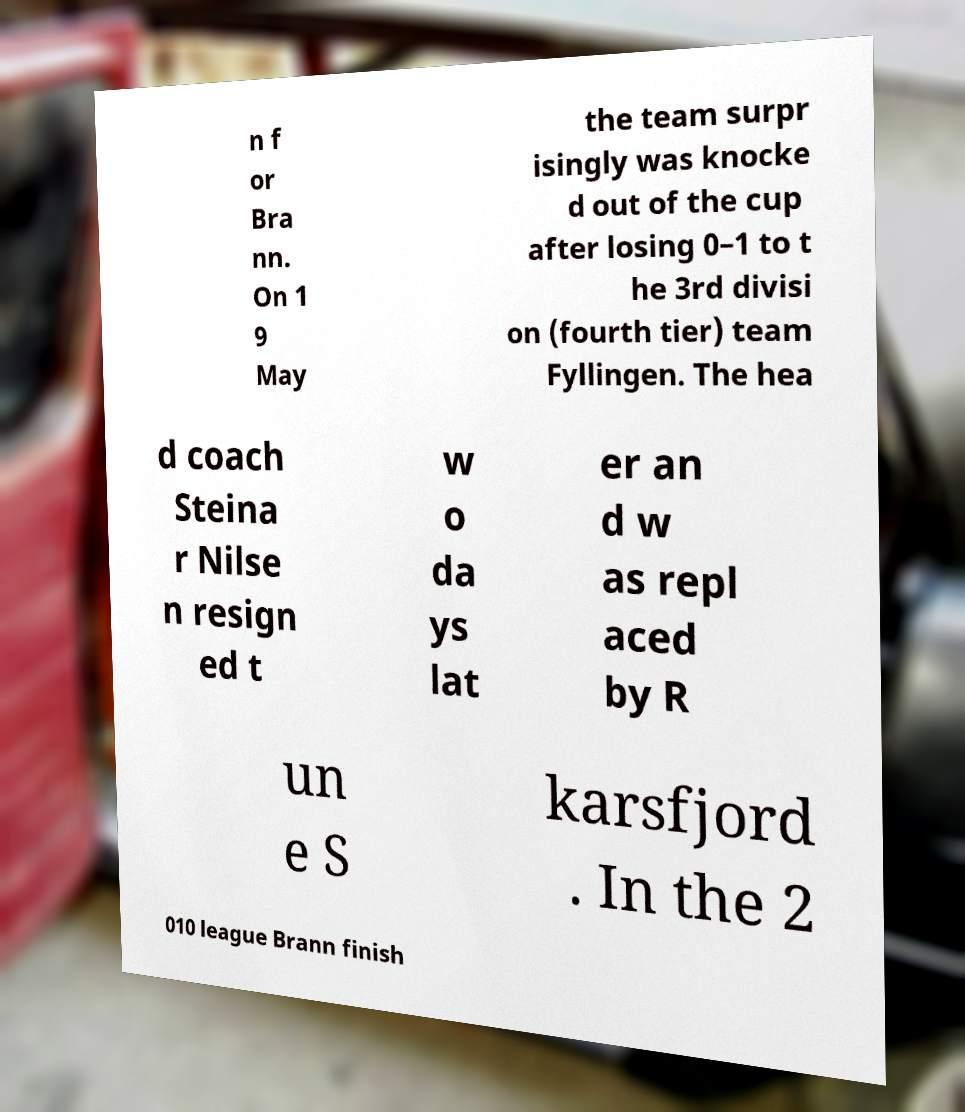I need the written content from this picture converted into text. Can you do that? n f or Bra nn. On 1 9 May the team surpr isingly was knocke d out of the cup after losing 0–1 to t he 3rd divisi on (fourth tier) team Fyllingen. The hea d coach Steina r Nilse n resign ed t w o da ys lat er an d w as repl aced by R un e S karsfjord . In the 2 010 league Brann finish 